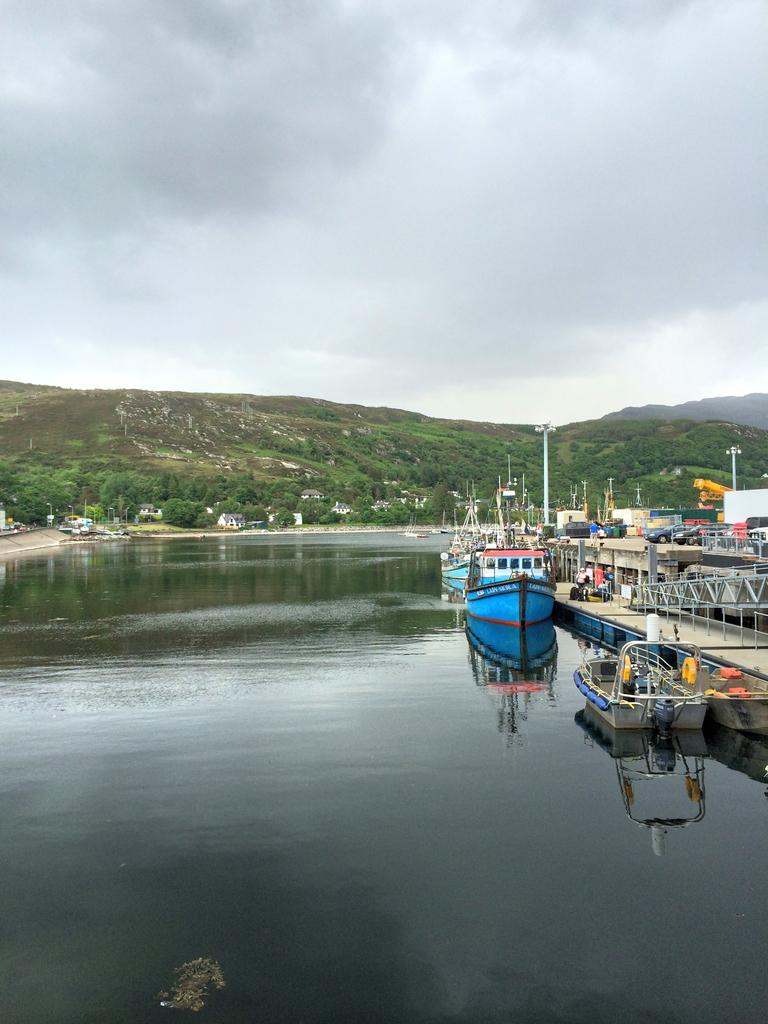What is on the water in the image? There are boats on the water in the image. What else can be seen in the image besides the boats? There are poles, lights, houses, trees, hills, and the sky visible in the image. What type of structures are present in the image? There are houses and poles in the image. What natural elements can be seen in the image? There are trees, hills, and the sky visible in the image. Where can the honey be found in the image? There is no honey present in the image. 